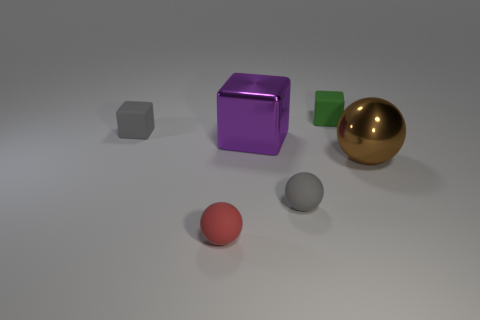Subtract all big purple blocks. How many blocks are left? 2 Add 3 tiny red metal blocks. How many objects exist? 9 Subtract all gray spheres. How many spheres are left? 2 Add 6 large objects. How many large objects are left? 8 Add 1 green blocks. How many green blocks exist? 2 Subtract 0 blue spheres. How many objects are left? 6 Subtract 3 blocks. How many blocks are left? 0 Subtract all brown spheres. Subtract all yellow cubes. How many spheres are left? 2 Subtract all green cylinders. How many purple balls are left? 0 Subtract all purple matte cubes. Subtract all big purple shiny objects. How many objects are left? 5 